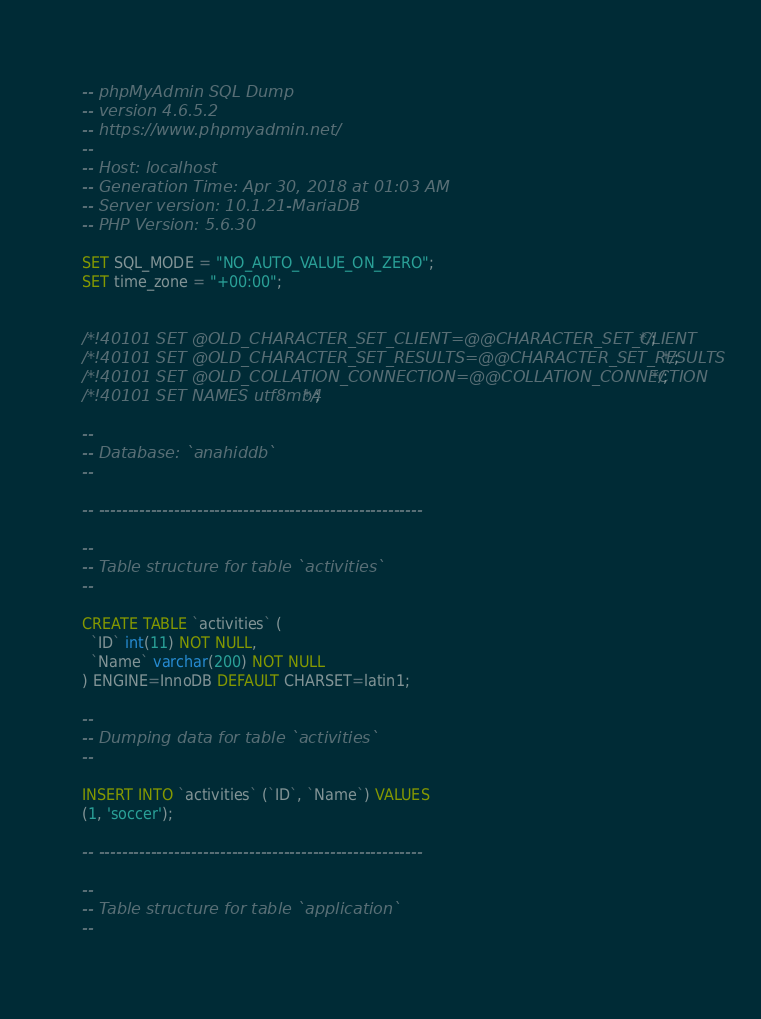Convert code to text. <code><loc_0><loc_0><loc_500><loc_500><_SQL_>-- phpMyAdmin SQL Dump
-- version 4.6.5.2
-- https://www.phpmyadmin.net/
--
-- Host: localhost
-- Generation Time: Apr 30, 2018 at 01:03 AM
-- Server version: 10.1.21-MariaDB
-- PHP Version: 5.6.30

SET SQL_MODE = "NO_AUTO_VALUE_ON_ZERO";
SET time_zone = "+00:00";


/*!40101 SET @OLD_CHARACTER_SET_CLIENT=@@CHARACTER_SET_CLIENT */;
/*!40101 SET @OLD_CHARACTER_SET_RESULTS=@@CHARACTER_SET_RESULTS */;
/*!40101 SET @OLD_COLLATION_CONNECTION=@@COLLATION_CONNECTION */;
/*!40101 SET NAMES utf8mb4 */;

--
-- Database: `anahiddb`
--

-- --------------------------------------------------------

--
-- Table structure for table `activities`
--

CREATE TABLE `activities` (
  `ID` int(11) NOT NULL,
  `Name` varchar(200) NOT NULL
) ENGINE=InnoDB DEFAULT CHARSET=latin1;

--
-- Dumping data for table `activities`
--

INSERT INTO `activities` (`ID`, `Name`) VALUES
(1, 'soccer');

-- --------------------------------------------------------

--
-- Table structure for table `application`
--
</code> 